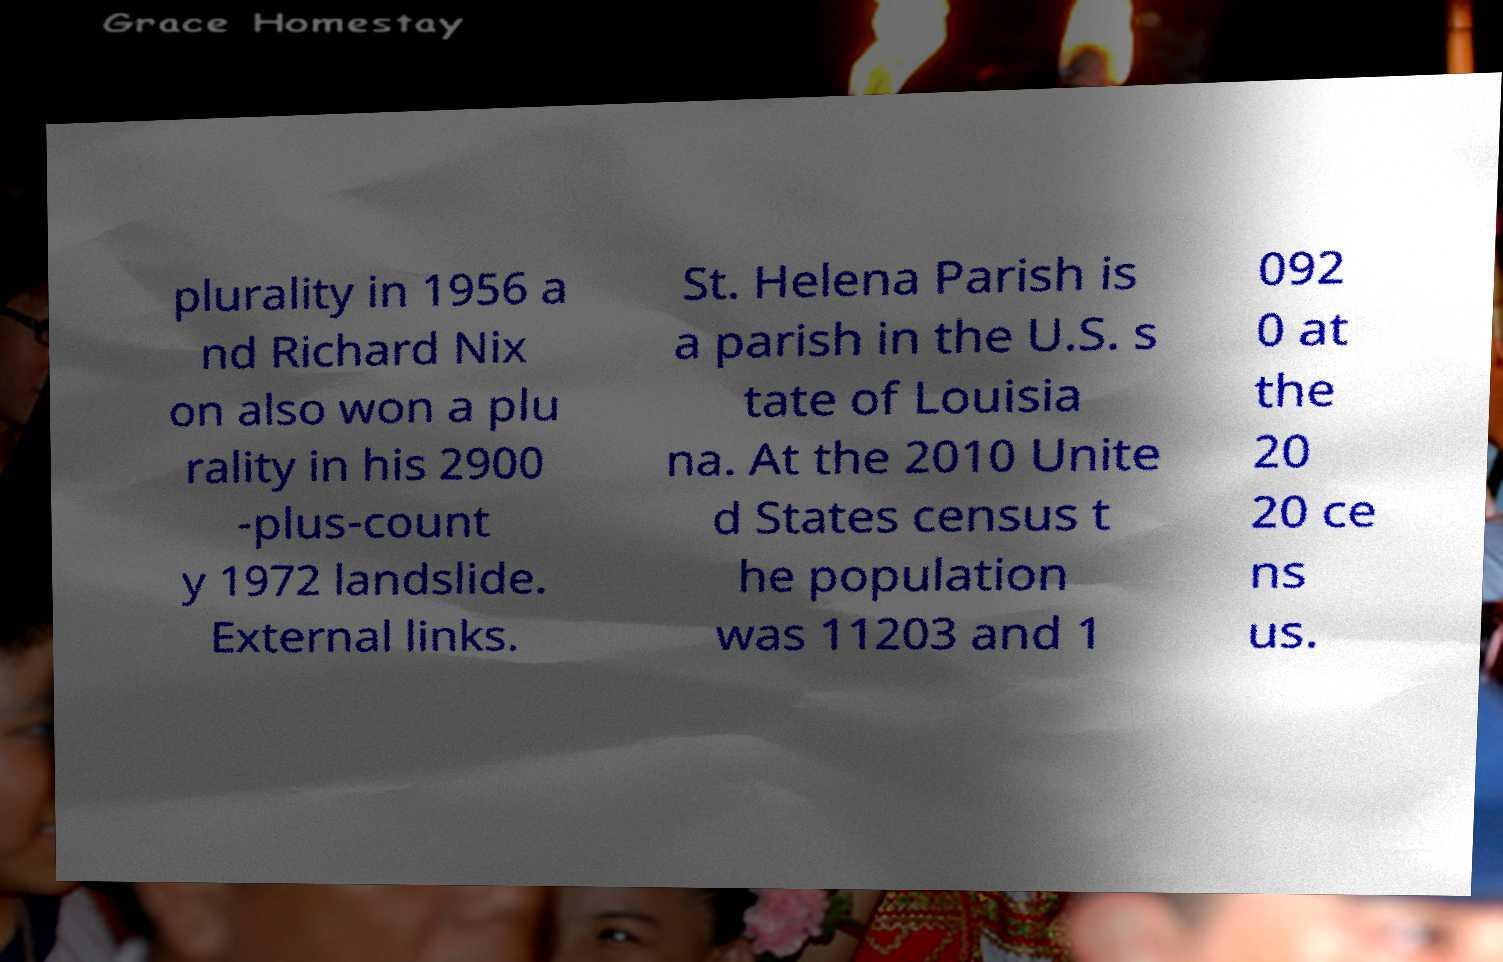Please identify and transcribe the text found in this image. plurality in 1956 a nd Richard Nix on also won a plu rality in his 2900 -plus-count y 1972 landslide. External links. St. Helena Parish is a parish in the U.S. s tate of Louisia na. At the 2010 Unite d States census t he population was 11203 and 1 092 0 at the 20 20 ce ns us. 